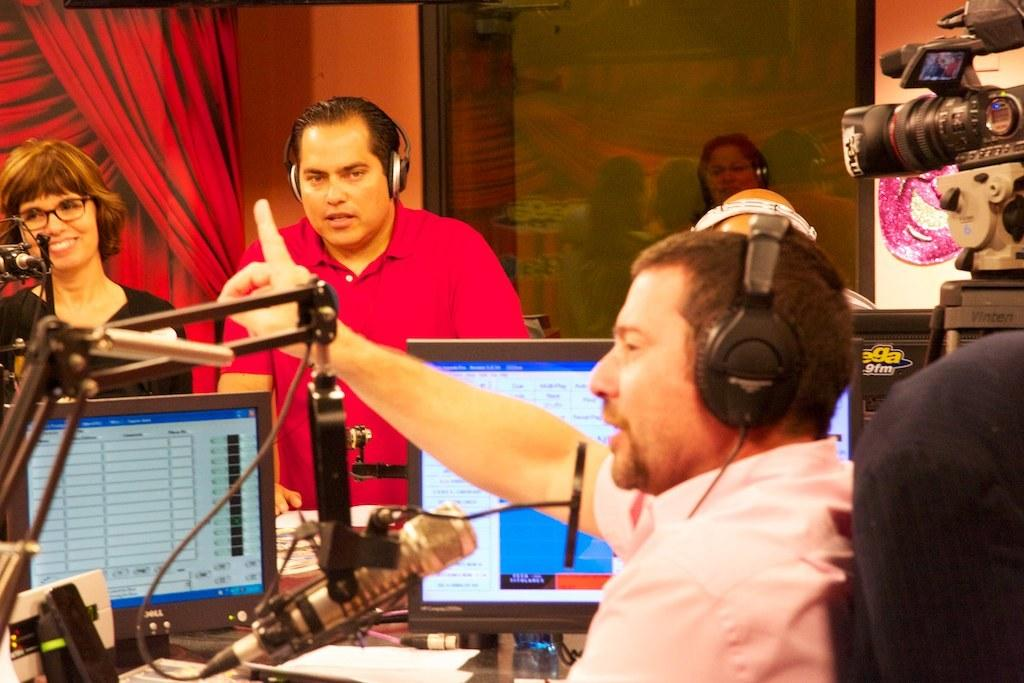Who or what is at the bottom of the image? There is a person at the bottom of the image. What is the person wearing? The person is wearing a headset. What can be seen on the left side of the image? There is a microphone on the left side of the image. What type of beef is being served at the committee meeting in the image? There is no beef or committee meeting present in the image. What kind of fowl can be seen flying in the background of the image? There is no fowl or background visible in the image; it only features a person wearing a headset and a microphone on the left side. 